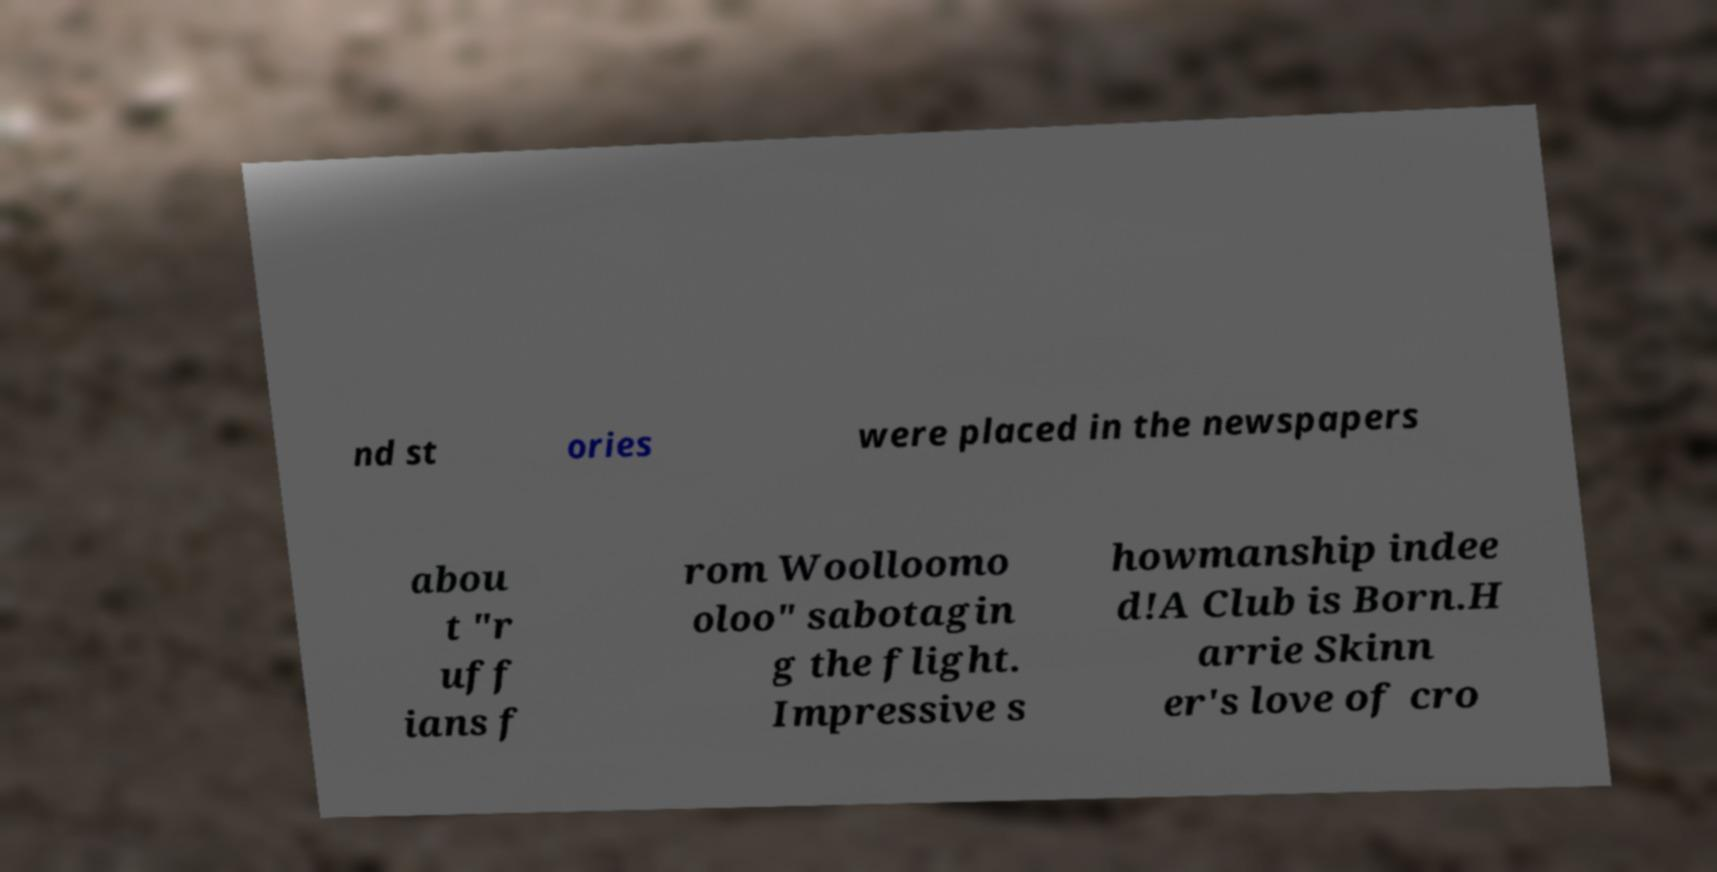There's text embedded in this image that I need extracted. Can you transcribe it verbatim? nd st ories were placed in the newspapers abou t "r uff ians f rom Woolloomo oloo" sabotagin g the flight. Impressive s howmanship indee d!A Club is Born.H arrie Skinn er's love of cro 